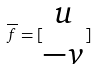<formula> <loc_0><loc_0><loc_500><loc_500>\overline { f } = [ \begin{matrix} u \\ - v \end{matrix} ]</formula> 